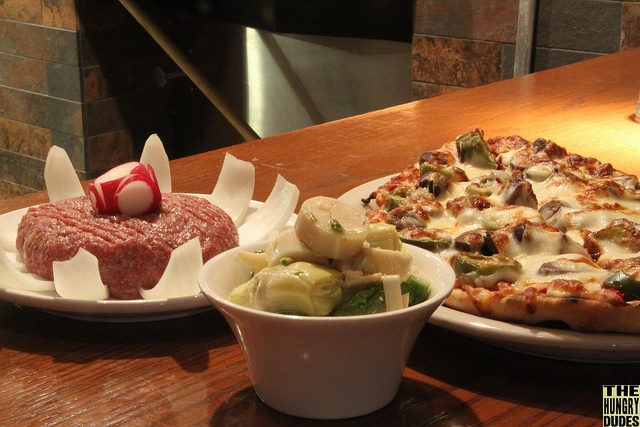Describe the objects in this image and their specific colors. I can see dining table in maroon, brown, black, and tan tones, pizza in maroon, brown, and tan tones, bowl in maroon, olive, and tan tones, and cake in maroon, salmon, brown, and tan tones in this image. 